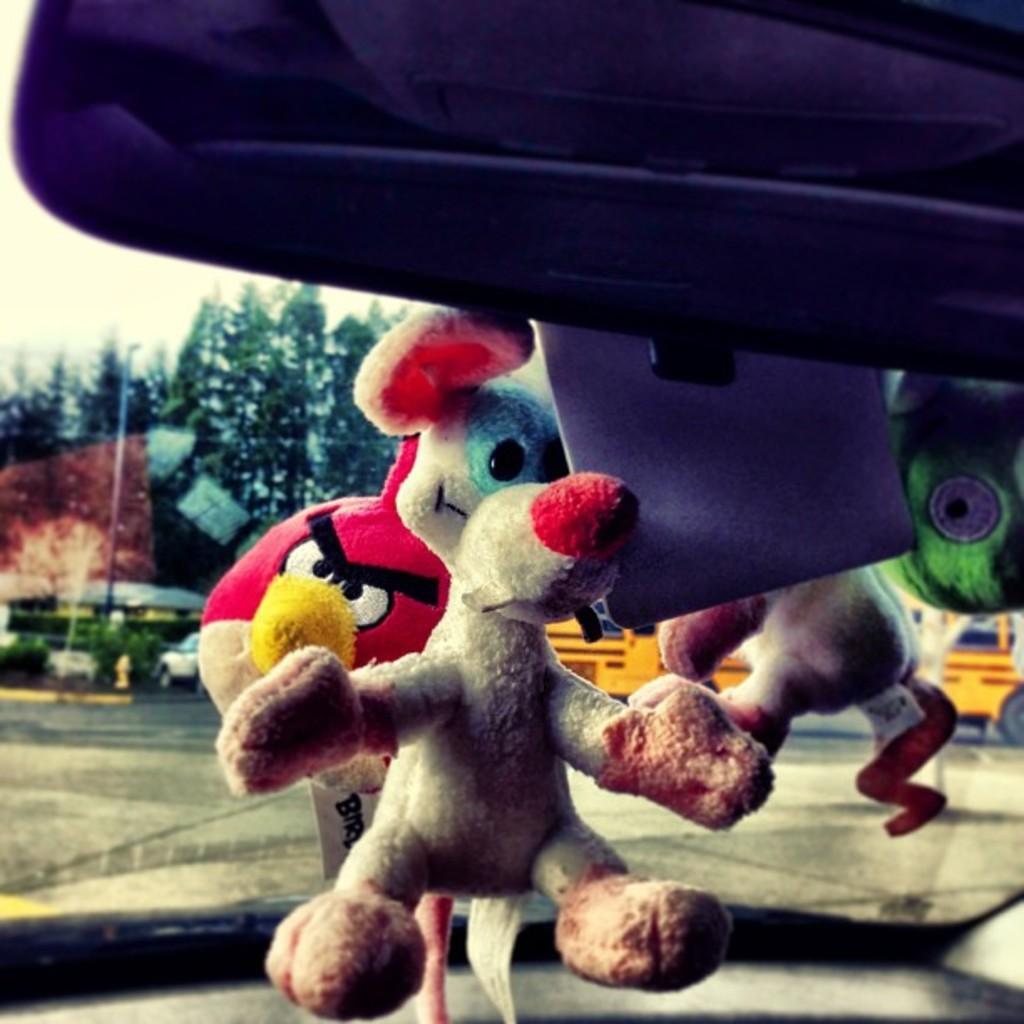Describe this image in one or two sentences. In this image we can see there are toys and an object. At the back there is a road and trees. And there is a pole and a vehicle. At the top there is a sky. 